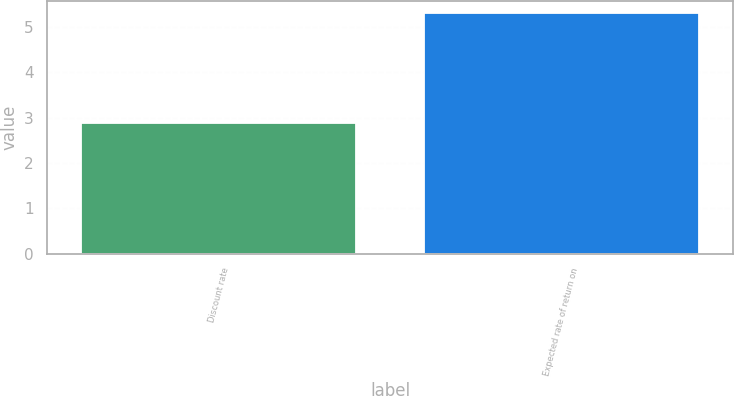Convert chart. <chart><loc_0><loc_0><loc_500><loc_500><bar_chart><fcel>Discount rate<fcel>Expected rate of return on<nl><fcel>2.88<fcel>5.3<nl></chart> 